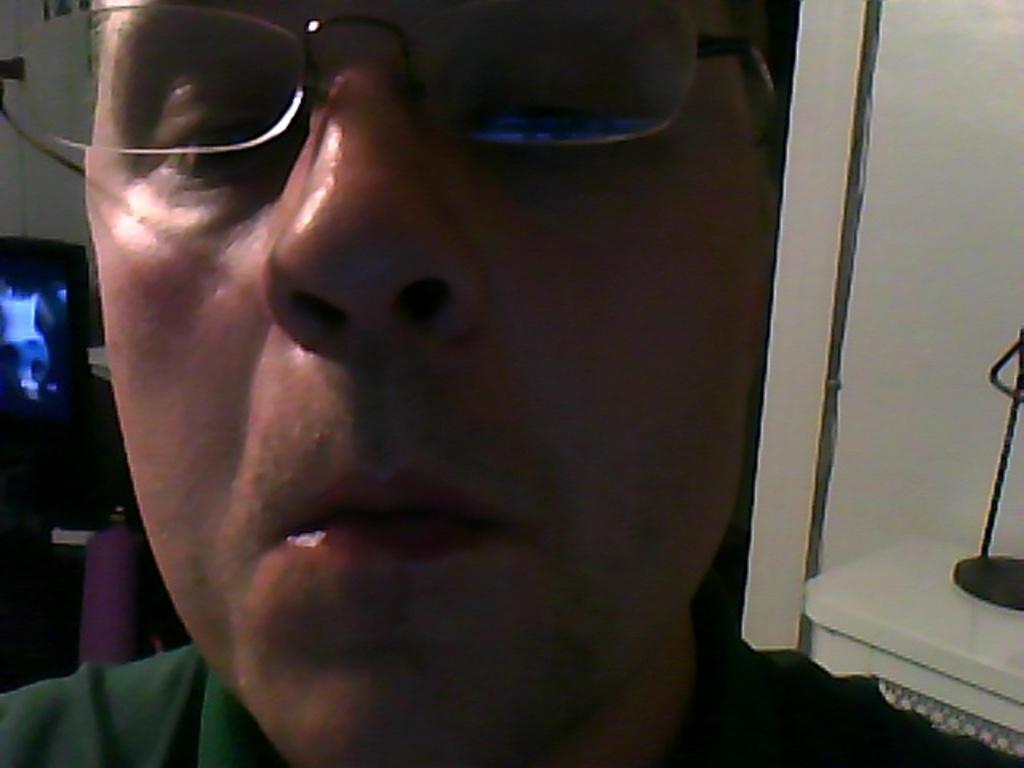Can you describe this image briefly? In this image we can see a person wearing spectacles and behind him we can see a metal object. 